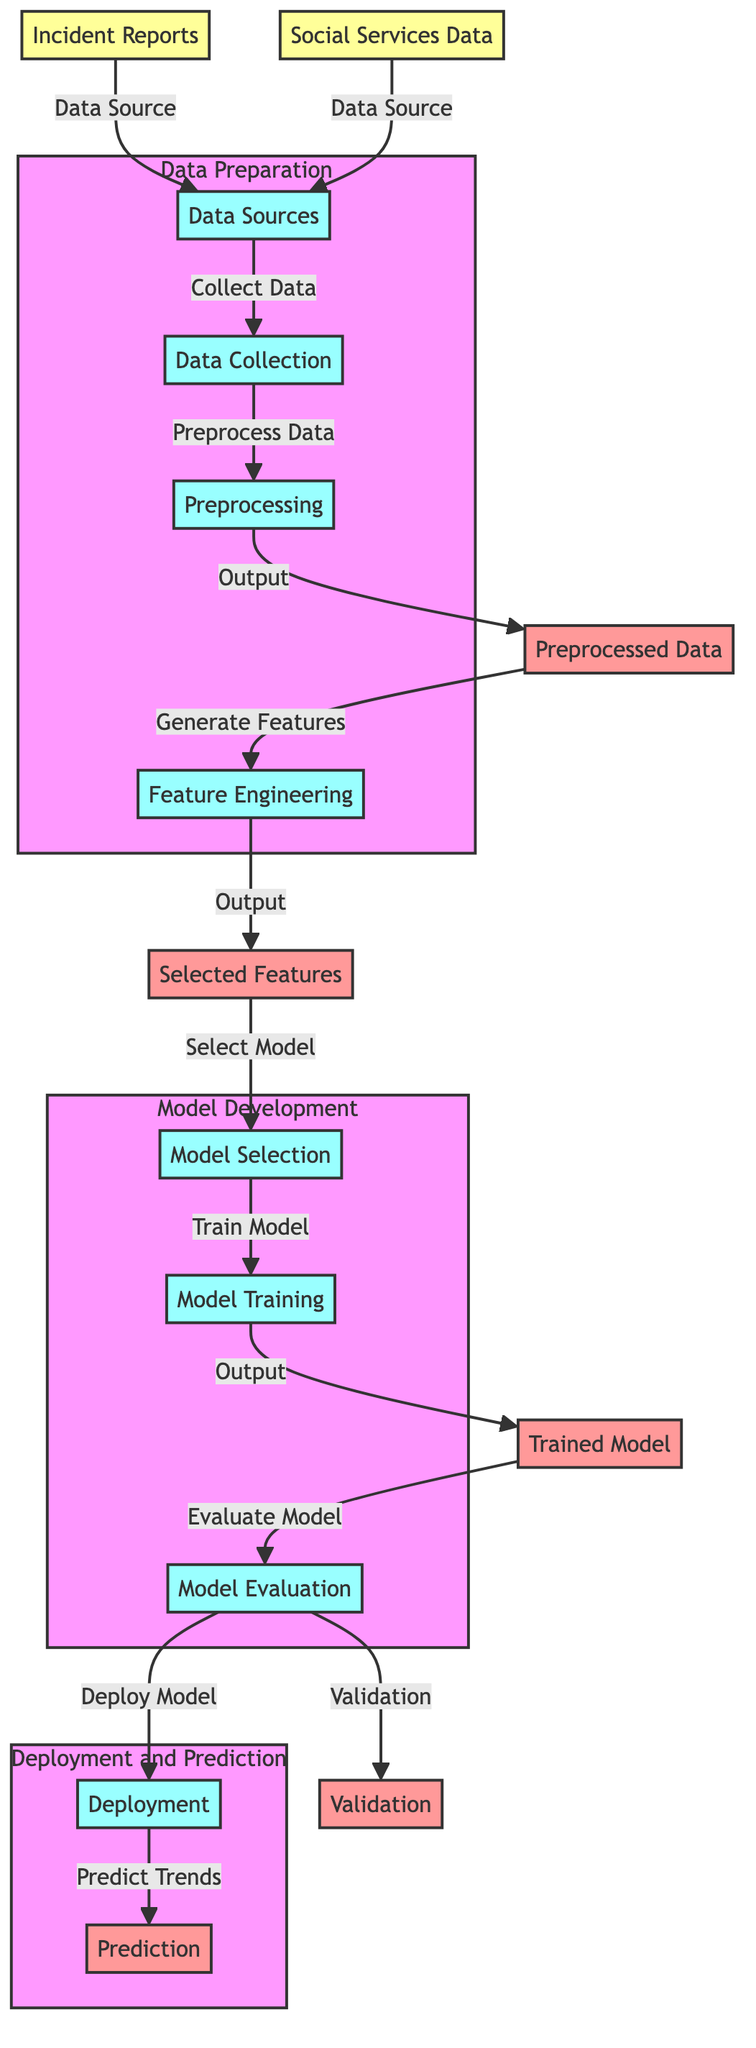What is the first step in the diagram? The diagram shows "Data Collection" as the first step, which connects to the "Data Sources." This indicates that collecting data is the initial action before any processing occurs.
Answer: Data Collection How many source nodes are in the diagram? The diagram includes two source nodes: "Incident Reports" and "Social Services Data." These nodes are where the data is obtained from to begin the process.
Answer: Two What follows after "Preprocessing" in the flow? After "Preprocessing," the flow continues to "Feature Engineering." This indicates that once data has been preprocessed, the next step is to generate features from the processed data.
Answer: Feature Engineering Which subgraph contains the "Model Training" process? The "Model Development" subgraph contains the "Model Training" process. This helps visualize that training the model is part of the broader model development actions taken to create a predictive model.
Answer: Model Development What is the output of the "Model Evaluation"? The output of the "Model Evaluation" includes both "Validation" and "Deploy Model." This means that the evaluation process results in validation of the model and its readiness for deployment.
Answer: Validation and Deploy Model Which node directly connects to "Prediction"? The "Deployment" node directly connects to "Prediction." This indicates that predictions occur after the model has been deployed, following all prior processes.
Answer: Deployment What is the purpose of the "Feature Engineering" node? The purpose of the "Feature Engineering" node is to generate features from the preprocessed data. This process is critical for selecting the features that will be used in the model selection and training steps.
Answer: Generate Features How does data flow into the "Preprocessed Data"? Data flows into "Preprocessed Data" from the "Preprocessing" node, with the indication that preprocessed data is the result of the data being cleaned and transformed before further analysis.
Answer: Preprocessing Which process comes after "Model Selection"? The process that comes directly after "Model Selection" is "Model Training." This denotes that once a model is chosen, the next step is to train it using the selected features.
Answer: Model Training 